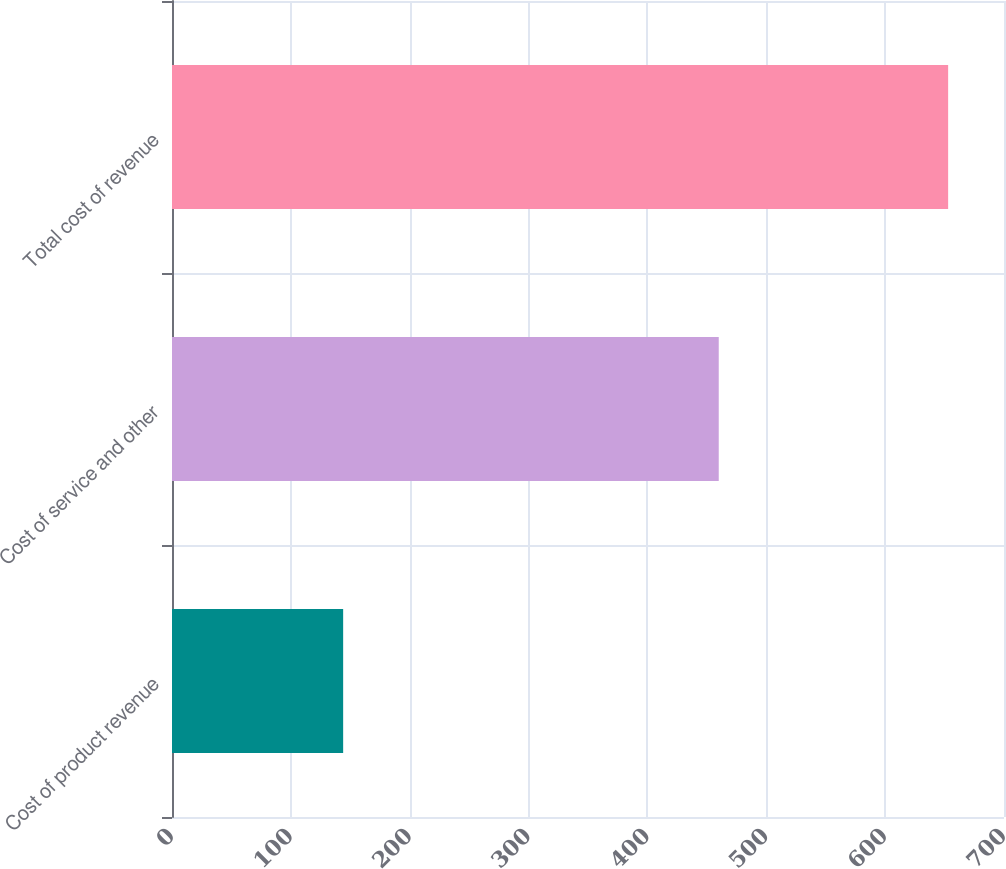Convert chart. <chart><loc_0><loc_0><loc_500><loc_500><bar_chart><fcel>Cost of product revenue<fcel>Cost of service and other<fcel>Total cost of revenue<nl><fcel>144<fcel>460<fcel>653<nl></chart> 